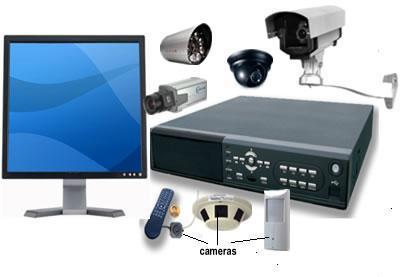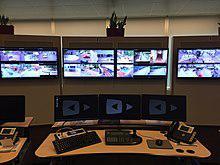The first image is the image on the left, the second image is the image on the right. Assess this claim about the two images: "An image shows the back of a man seated before many screens.". Correct or not? Answer yes or no. No. The first image is the image on the left, the second image is the image on the right. For the images displayed, is the sentence "An image shows a man reaching to touch a control panel." factually correct? Answer yes or no. No. 